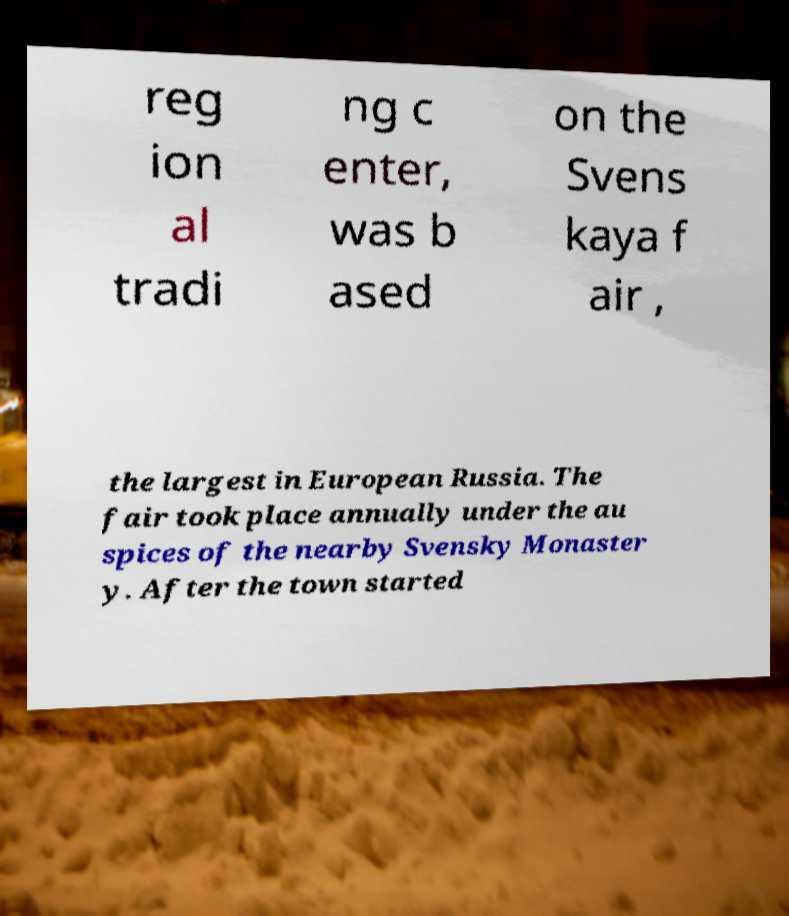Can you accurately transcribe the text from the provided image for me? reg ion al tradi ng c enter, was b ased on the Svens kaya f air , the largest in European Russia. The fair took place annually under the au spices of the nearby Svensky Monaster y. After the town started 